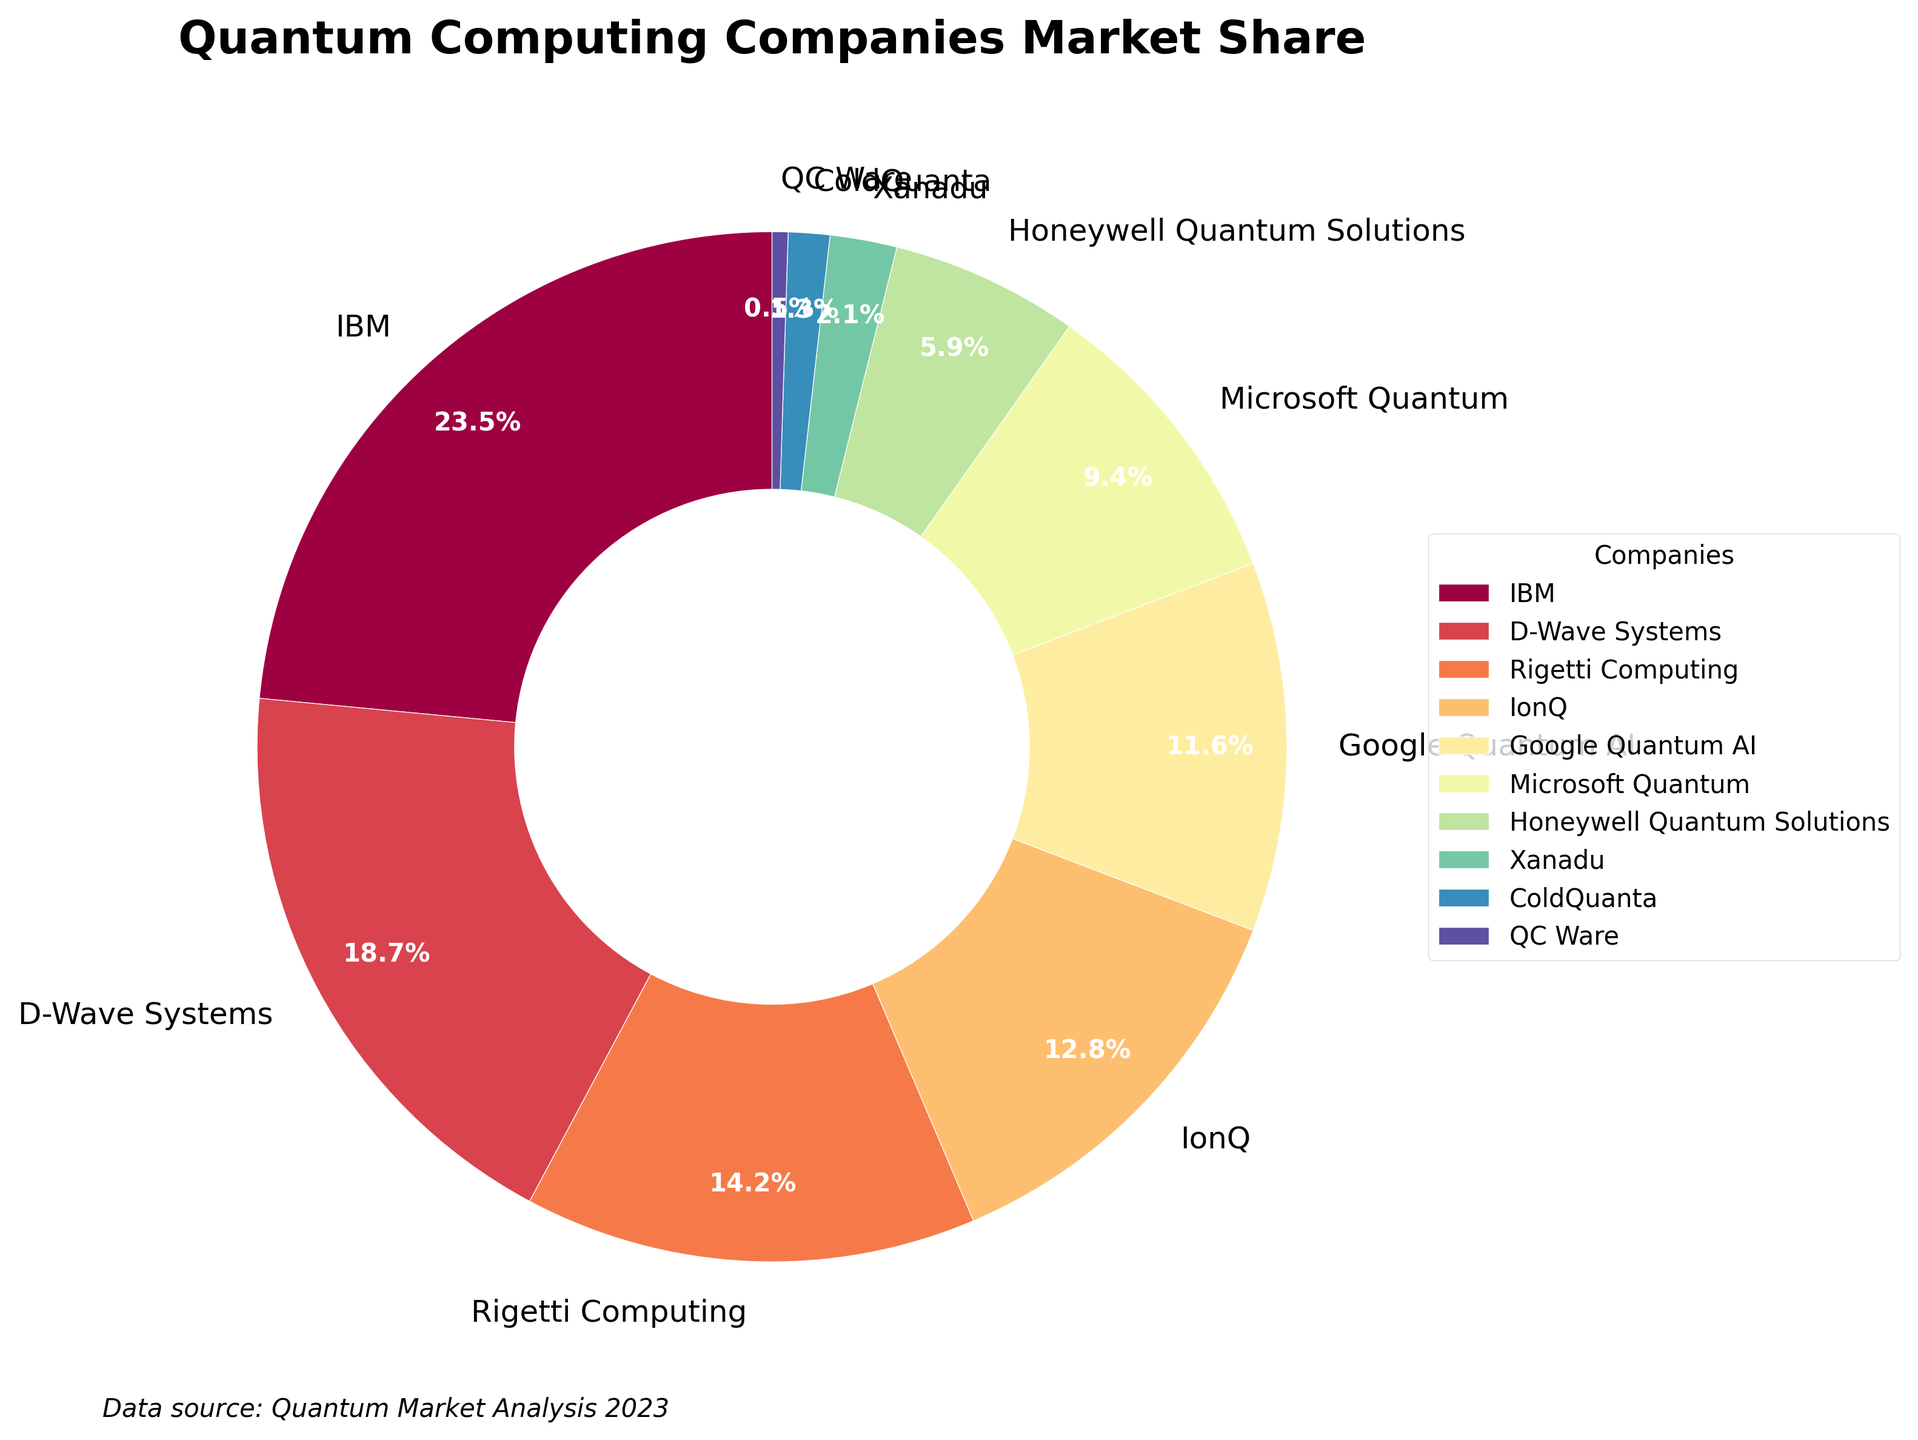IBM has the largest market share in the quantum computing space. How much is it? Look at the slice labeled "IBM" and its corresponding percentage. IBM's market share is shown directly on its slice.
Answer: 23.5% What's the combined market share of Rigetti Computing and IonQ? Identify the slices labeled "Rigetti Computing" and "IonQ" and note their percentages. Rigetti Computing has a market share of 14.2% and IonQ has 12.8%. Add these two values together: 14.2 + 12.8 = 27.0%.
Answer: 27.0% Which company has the smallest market share, and what is it? Find the smallest slice in the pie chart, which corresponds to the company with the least market share. Look at the label to find the company and its percentage.
Answer: QC Ware, 0.5% Is the market share of Google Quantum AI more or less than that of Microsoft Quantum? Compare the slices labeled "Google Quantum AI" and "Microsoft Quantum". Google Quantum AI has a market share of 11.6% while Microsoft Quantum has a market share of 9.4%. Since 11.6% is greater than 9.4%, Google Quantum AI has a higher market share.
Answer: More What's the total market share of companies with less than 10% each? Identify the slices of companies with market shares below 10%: Microsoft Quantum (9.4%), Honeywell Quantum Solutions (5.9%), Xanadu (2.1%), ColdQuanta (1.3%), and QC Ware (0.5%). Add these percentages together: 9.4 + 5.9 + 2.1 + 1.3 + 0.5 = 19.2%.
Answer: 19.2% How does the market share of D-Wave Systems compare to that of Honeywell Quantum Solutions? Look at the percentages for D-Wave Systems and Honeywell Quantum Solutions. D-Wave Systems has 18.7% and Honeywell Quantum Solutions has 5.9%. Compare these two values.
Answer: D-Wave Systems has a higher market share What percentage of the market is controlled by the top three companies combined? Identify the top three companies by their percentages: IBM (23.5%), D-Wave Systems (18.7%), and Rigetti Computing (14.2%). Add these percentages together: 23.5 + 18.7 + 14.2 = 56.4%.
Answer: 56.4% Which company's slice is visually represented with a distinct color at one o’clock position in the pie chart? Locate the slice at approximately the one o'clock position in the pie chart and note its label. The slice at this position will be colored differently from its neighbors.
Answer: Google Quantum AI What's the average market share of IonQ and Microsoft Quantum? Find the percentages for IonQ (12.8%) and Microsoft Quantum (9.4%). Add these two values together and then divide by 2 to find the average: (12.8 + 9.4) / 2 = 22.2 / 2 = 11.1%.
Answer: 11.1% Who is the market leader in the quantum computing industry according to this chart, and by how much do they lead over the second largest company? Identify the company with the largest market share (IBM with 23.5%) and the second largest (D-Wave Systems with 18.7%). Find the difference between their market shares: 23.5 - 18.7 = 4.8%.
Answer: IBM, by 4.8% 